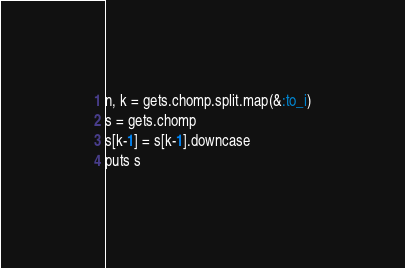<code> <loc_0><loc_0><loc_500><loc_500><_Ruby_>n, k = gets.chomp.split.map(&:to_i)
s = gets.chomp
s[k-1] = s[k-1].downcase
puts s

</code> 